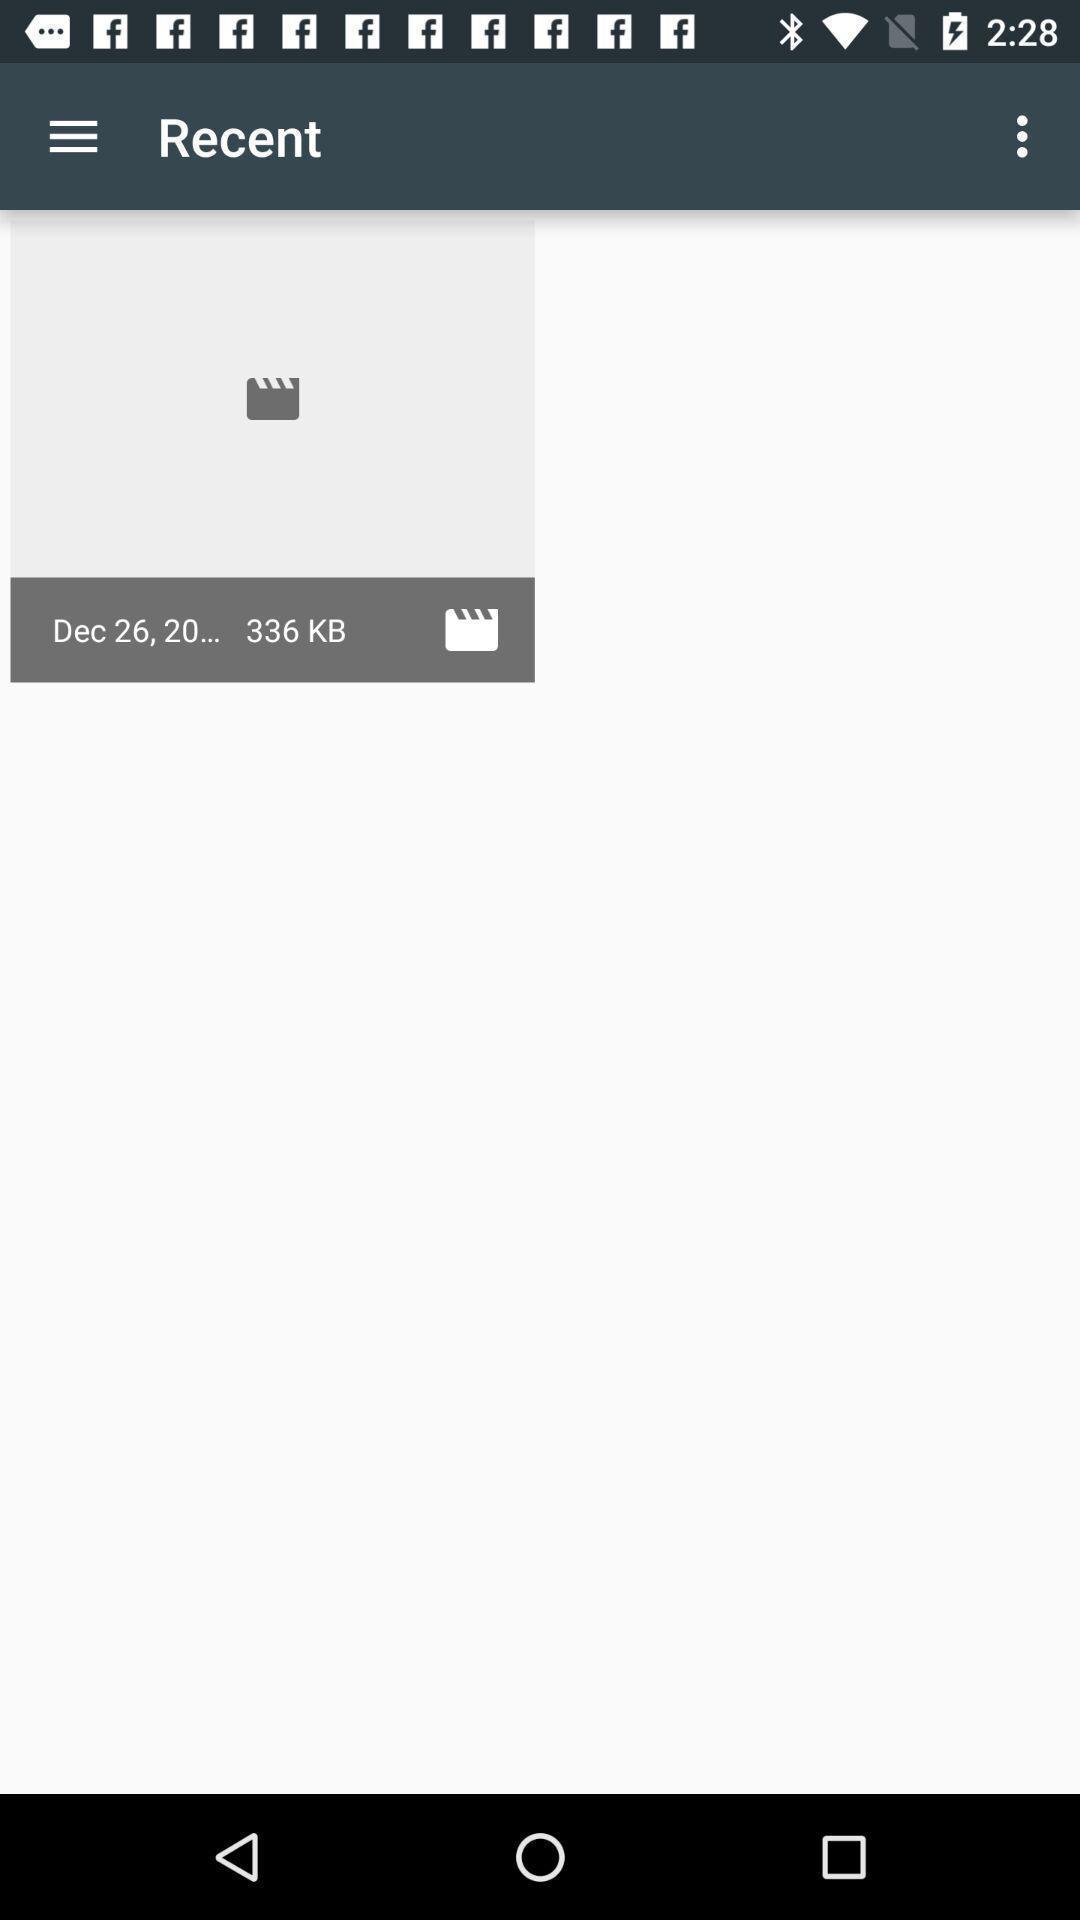Describe the key features of this screenshot. Screen showing image. 